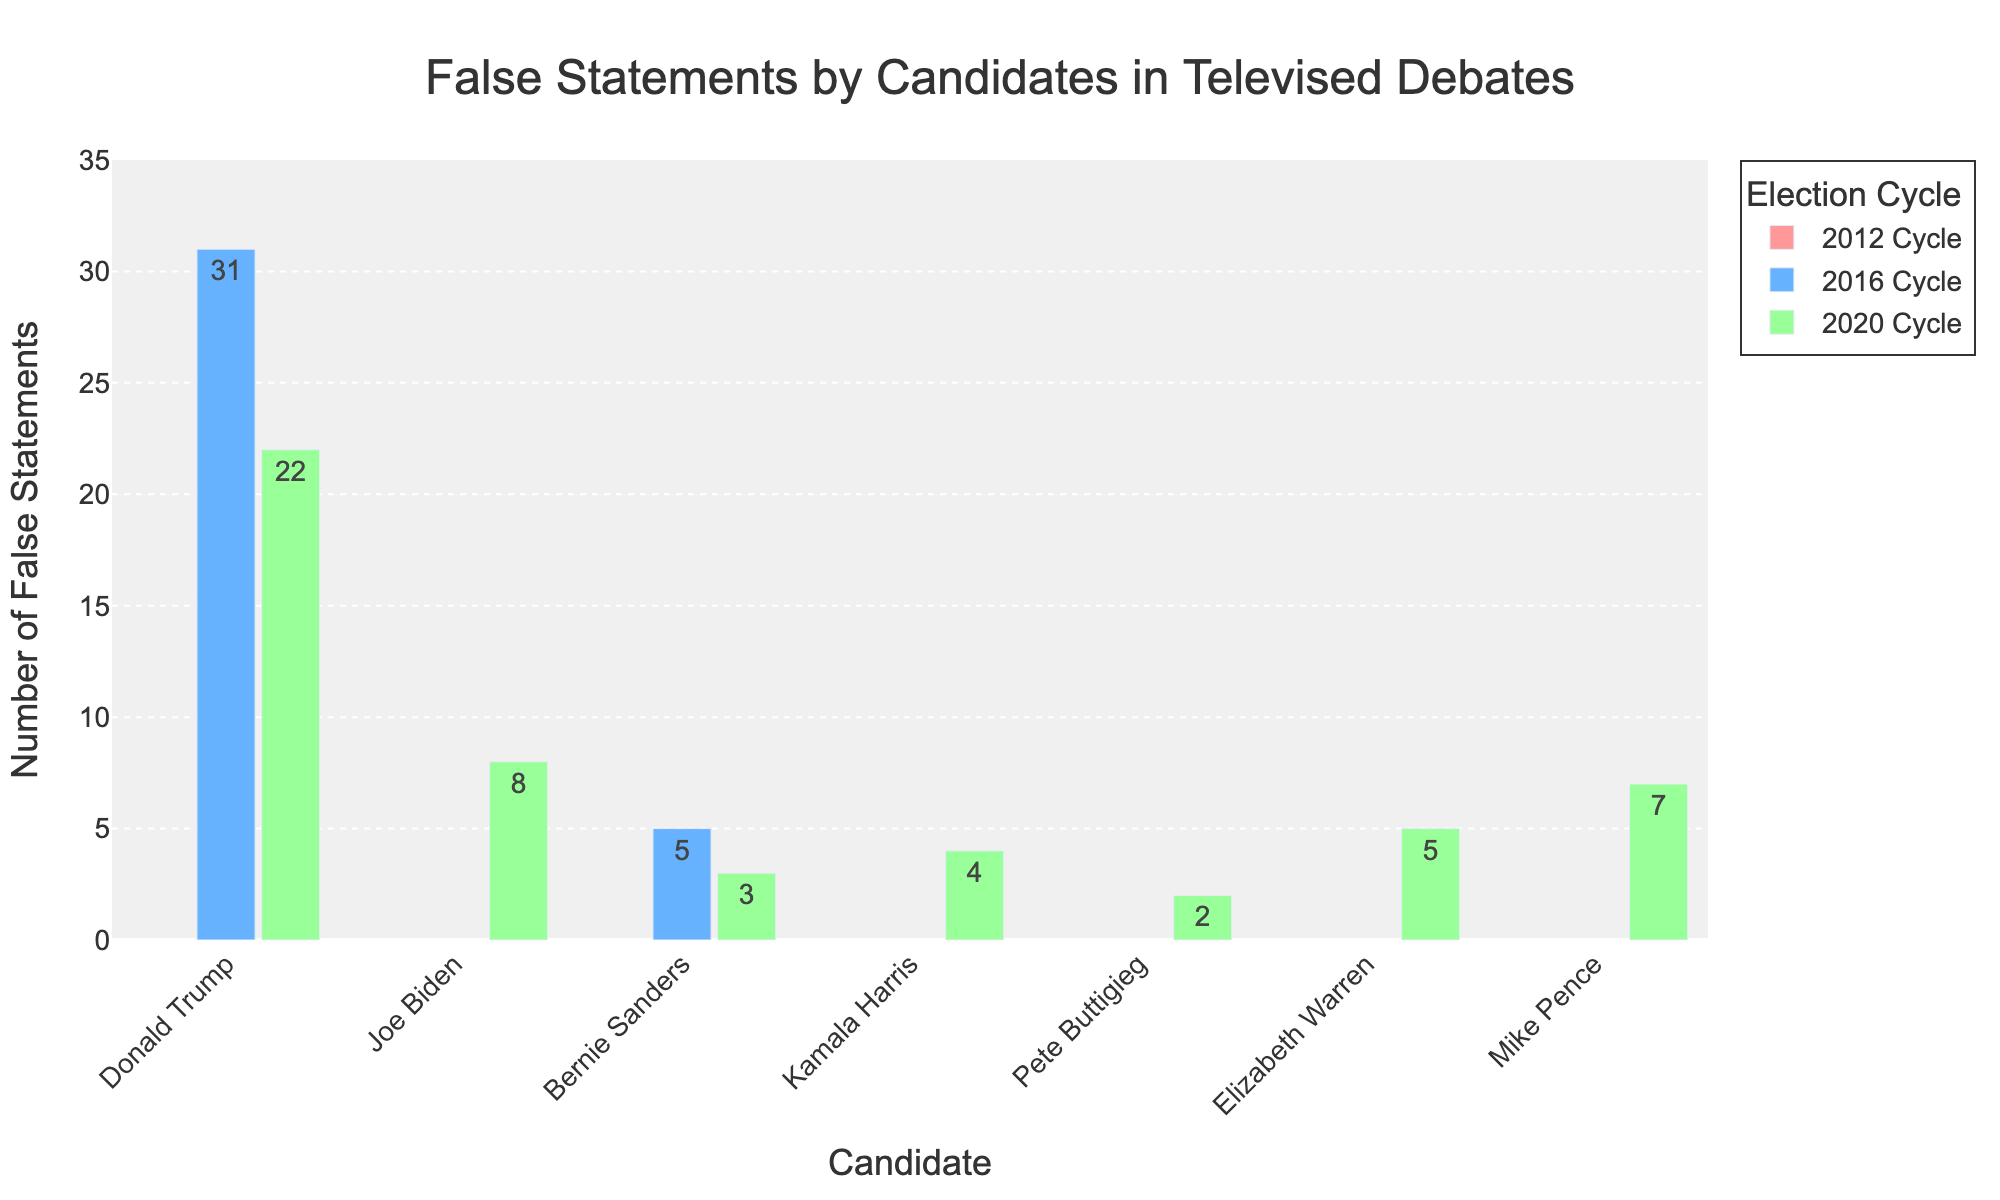What are the total number of false statements made by all candidates in the 2020 cycle? Look at the number of false statements for each candidate in the 2020 cycle and sum them: Donald Trump (22) + Joe Biden (8) + Bernie Sanders (3) + Kamala Harris (4) + Pete Buttigieg (2) + Elizabeth Warren (5) + Mike Pence (7) = 51
Answer: 51 Which candidate made more false statements in the 2016 cycle, Donald Trump or Bernie Sanders? Compare the number of false statements: Donald Trump (31) vs Bernie Sanders (5).
Answer: Donald Trump How many more false statements did Donald Trump make than Joe Biden in the 2020 cycle? Subtract the number of false statements made by Joe Biden from those made by Donald Trump: 22 - 8 = 14
Answer: 14 Which candidate had the lowest number of false statements in the 2020 cycle? Look for the smallest value in the 2020 cycle: Pete Buttigieg with 2 false statements.
Answer: Pete Buttigieg Did any candidate make false statements in both the 2016 and 2020 cycles? If so, who? Check the candidates listed in both cycles: Bernie Sanders had false statements in both 2016 (5) and 2020 (3).
Answer: Bernie Sanders Compare the total number of false statements made by Donald Trump across the 2016 and 2020 cycles. Add the number of false statements made by Donald Trump in both cycles: 31 (2016) + 22 (2020) = 53
Answer: 53 Who made the greatest total number of false statements in the given data? Sum the false statements for each candidate across all cycles and find the highest total: Donald Trump (31 + 22 = 53)
Answer: Donald Trump If the number of false statements made by Joe Biden in the next election cycle equals the number made in the 2020 cycle, what would be his total number of false statements across both cycles? Double the 2020 cycle number for Joe Biden: 8 (2020) + 8 (next cycle) = 16
Answer: 16 Calculate the average number of false statements made by Bernie Sanders across all the election cycles provided. Divide the total number of false statements by the number of cycles he participated in: (5 [2016] + 3 [2020])/2 = 4
Answer: 4 